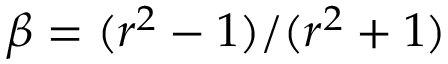<formula> <loc_0><loc_0><loc_500><loc_500>\beta = ( r ^ { 2 } - 1 ) / ( r ^ { 2 } + 1 )</formula> 